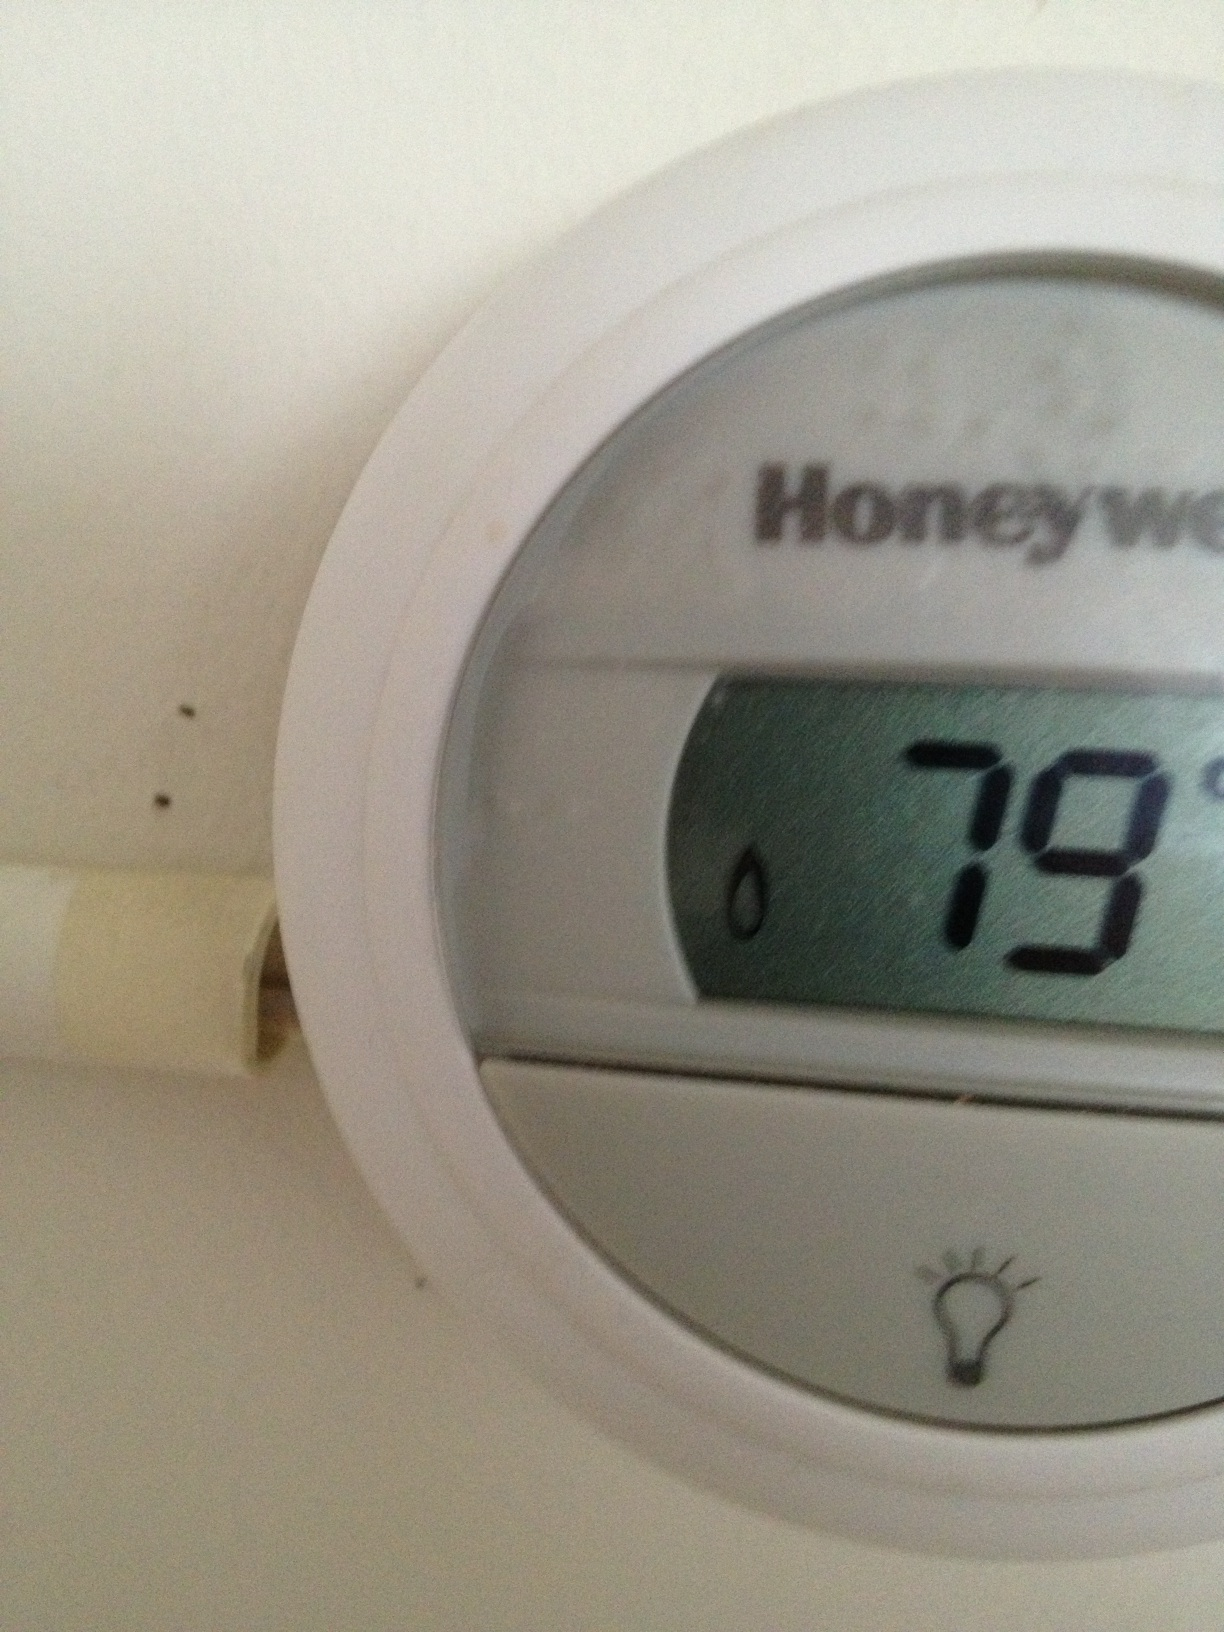Is this a heating or cooling setting? The thermostat is set to 79 degrees. Without additional context, it's not clear whether this is for heating or cooling. Typically, such settings depend on the user's preference and the external weather conditions. 